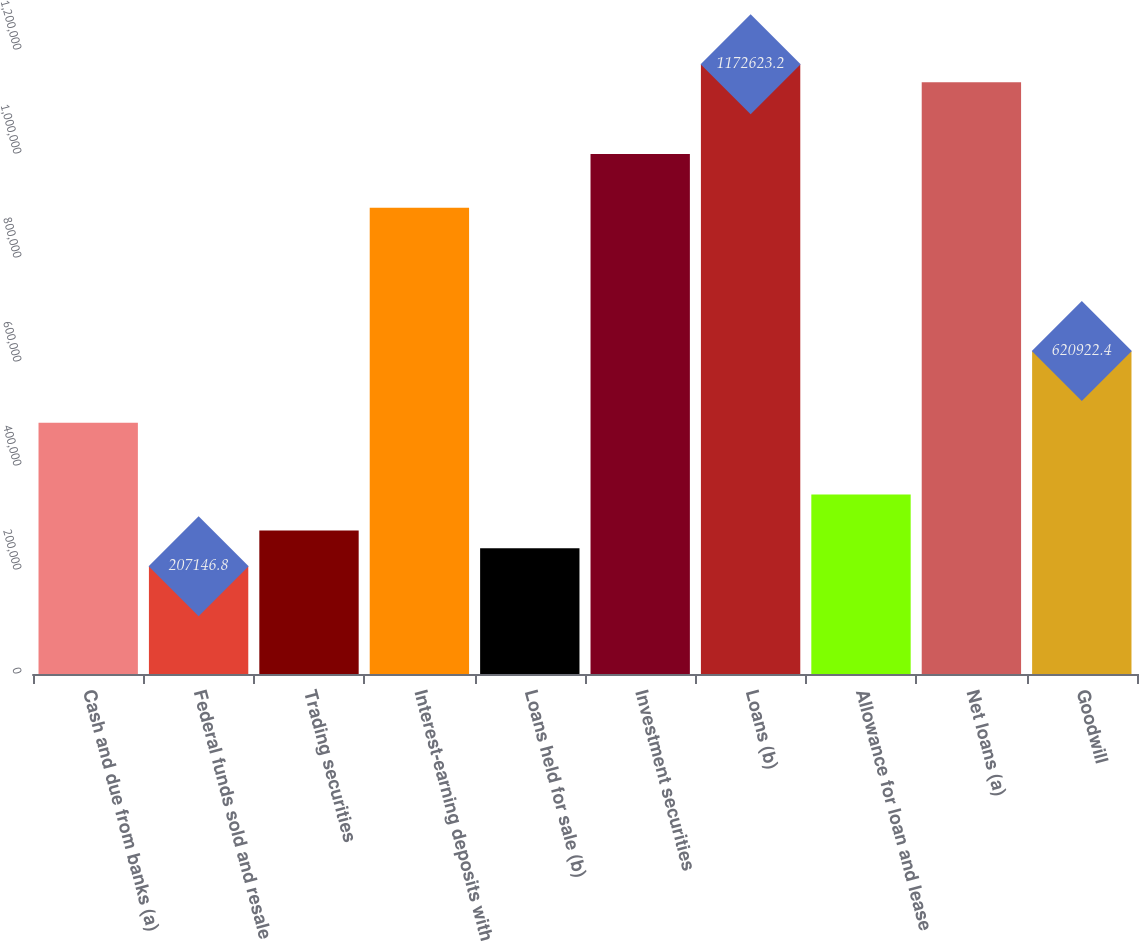Convert chart. <chart><loc_0><loc_0><loc_500><loc_500><bar_chart><fcel>Cash and due from banks (a)<fcel>Federal funds sold and resale<fcel>Trading securities<fcel>Interest-earning deposits with<fcel>Loans held for sale (b)<fcel>Investment securities<fcel>Loans (b)<fcel>Allowance for loan and lease<fcel>Net loans (a)<fcel>Goodwill<nl><fcel>482997<fcel>207147<fcel>276109<fcel>896773<fcel>241628<fcel>1.00022e+06<fcel>1.17262e+06<fcel>345072<fcel>1.13814e+06<fcel>620922<nl></chart> 